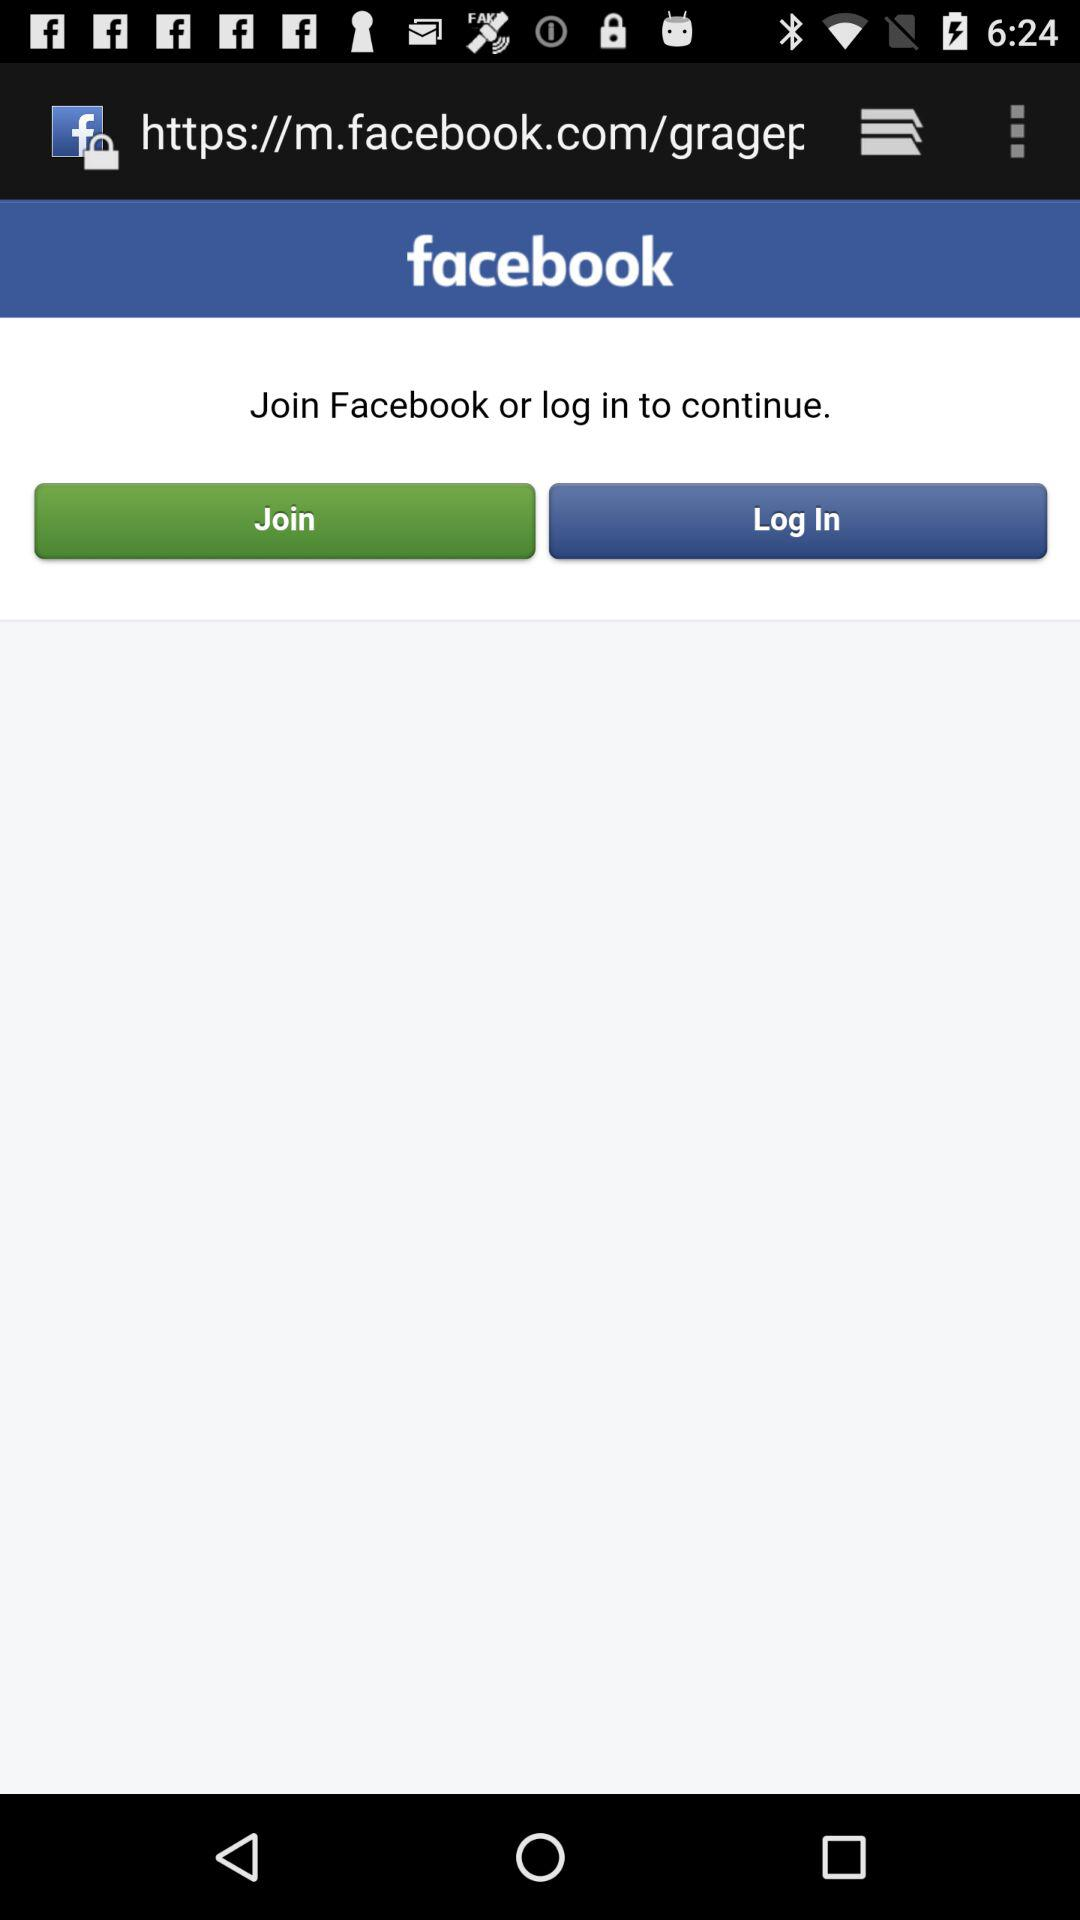What is the name of the application? The name of the application is "Facebook". 